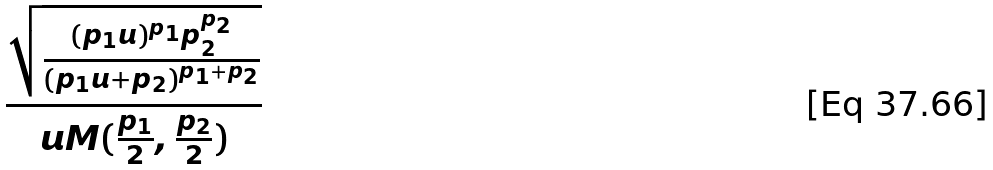<formula> <loc_0><loc_0><loc_500><loc_500>\frac { \sqrt { \frac { ( p _ { 1 } u ) ^ { p _ { 1 } } p _ { 2 } ^ { p _ { 2 } } } { ( p _ { 1 } u + p _ { 2 } ) ^ { p _ { 1 } + p _ { 2 } } } } } { u M ( \frac { p _ { 1 } } { 2 } , \frac { p _ { 2 } } { 2 } ) }</formula> 